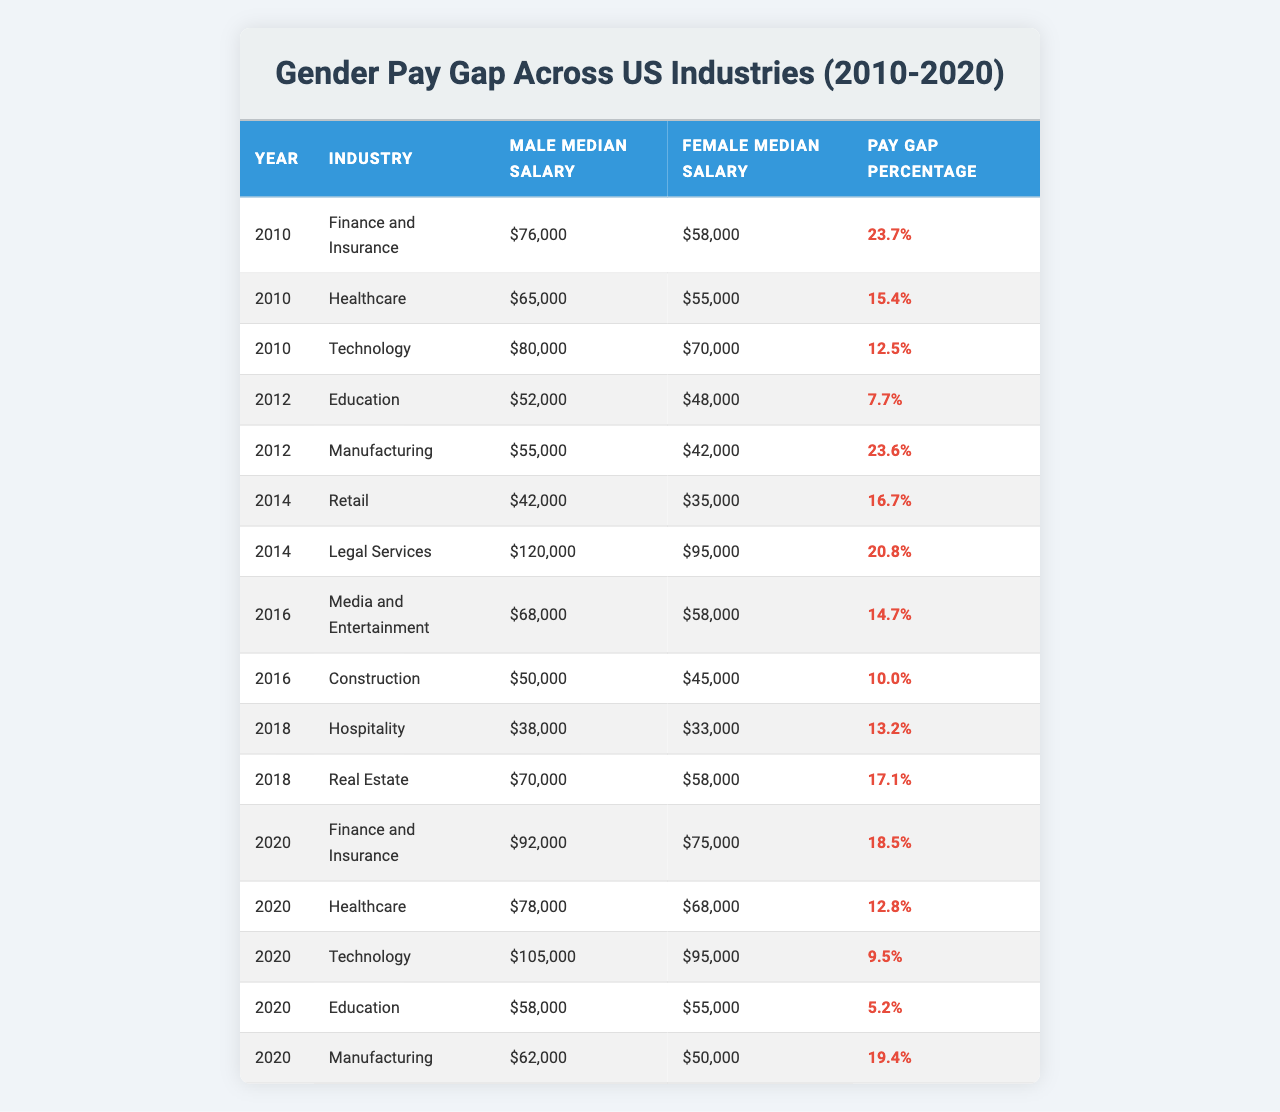What was the male median salary in the Technology industry in 2020? In the row corresponding to the Technology industry in the year 2020, the male median salary listed is $105,000.
Answer: $105,000 What percentage was the pay gap in the Manufacturing industry in 2016? In the Manufacturing industry for the year 2016, the pay gap percentage is stated as 10.0%.
Answer: 10.0% Which industry had the highest pay gap percentage in 2010? Reviewing the pay gap percentages for 2010, the Finance and Insurance industry has the highest percentage at 23.7%.
Answer: Finance and Insurance What was the average male median salary across all industries in 2018? The male median salaries for 2018 are $38,000 (Hospitality) + $70,000 (Real Estate) = $108,000. There are 2 industries, so the average male median salary is $108,000 / 2 = $54,000.
Answer: $54,000 Did the female median salary in Education improve from 2010 to 2020? The female median salary in Education was $48,000 in 2012 and increased to $55,000 in 2020, indicating an improvement.
Answer: Yes What was the change in the pay gap percentage for Healthcare from 2010 to 2020? The pay gap percentage for Healthcare was 15.4% in 2010 and decreased to 12.8% in 2020. The change is 15.4% - 12.8% = 2.6%.
Answer: 2.6% Which industry had the smallest pay gap in 2020? In 2020, the Education industry had the smallest pay gap percentage of 5.2%.
Answer: Education What is the difference in male median salary between Finance and Insurance and Healthcare in 2020? The male median salary for Finance and Insurance in 2020 is $92,000 and for Healthcare is $78,000. The difference is $92,000 - $78,000 = $14,000.
Answer: $14,000 In which year was the pay gap in the Legal Services industry the largest? The Legal Services industry had a pay gap of 20.8% in 2014, which is its only recorded pay gap in the data. Hence, this is the largest.
Answer: 2014 Is it true that the Technology industry consistently had a lower pay gap percentage than the Finance and Insurance industry from 2010 to 2020? In 2010, the Finance and Insurance industry had a pay gap of 23.7% compared to Technology's 12.5%. In 2020, Finance and Insurance had a pay gap of 18.5% compared to Technology's 9.5%. Technology had a lower pay gap percentage in both years.
Answer: Yes What was the female median salary in the Construction industry in 2016? The table shows that the female median salary in the Construction industry for 2016 was $45,000.
Answer: $45,000 